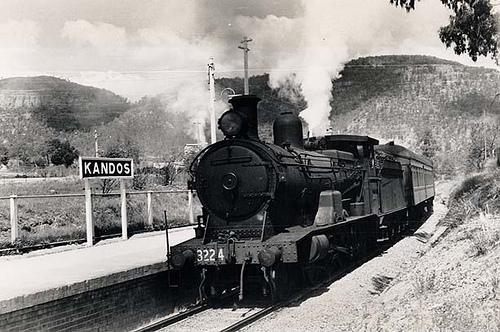Is the train blowing steam?
Give a very brief answer. Yes. What is the name of this station?
Write a very short answer. Kandos. What quality is the photo?
Answer briefly. Black and white. 